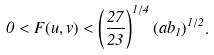Convert formula to latex. <formula><loc_0><loc_0><loc_500><loc_500>0 < F ( u , v ) < \left ( \frac { 2 7 } { 2 3 } \right ) ^ { 1 / 4 } ( a b _ { 1 } ) ^ { 1 / 2 } .</formula> 